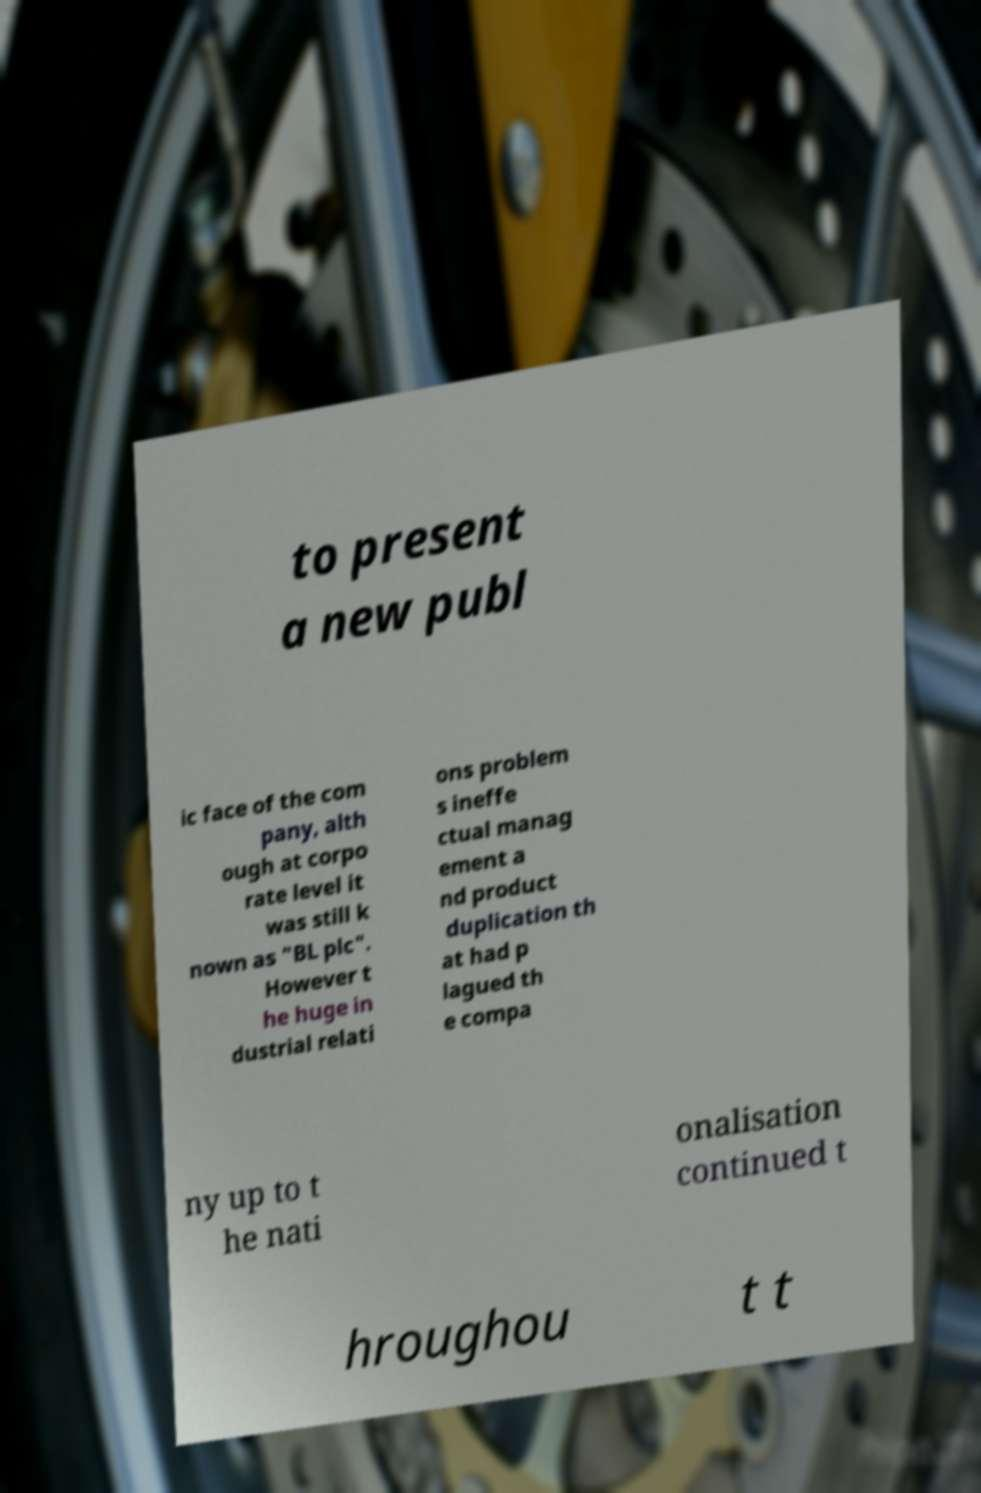What messages or text are displayed in this image? I need them in a readable, typed format. to present a new publ ic face of the com pany, alth ough at corpo rate level it was still k nown as "BL plc". However t he huge in dustrial relati ons problem s ineffe ctual manag ement a nd product duplication th at had p lagued th e compa ny up to t he nati onalisation continued t hroughou t t 